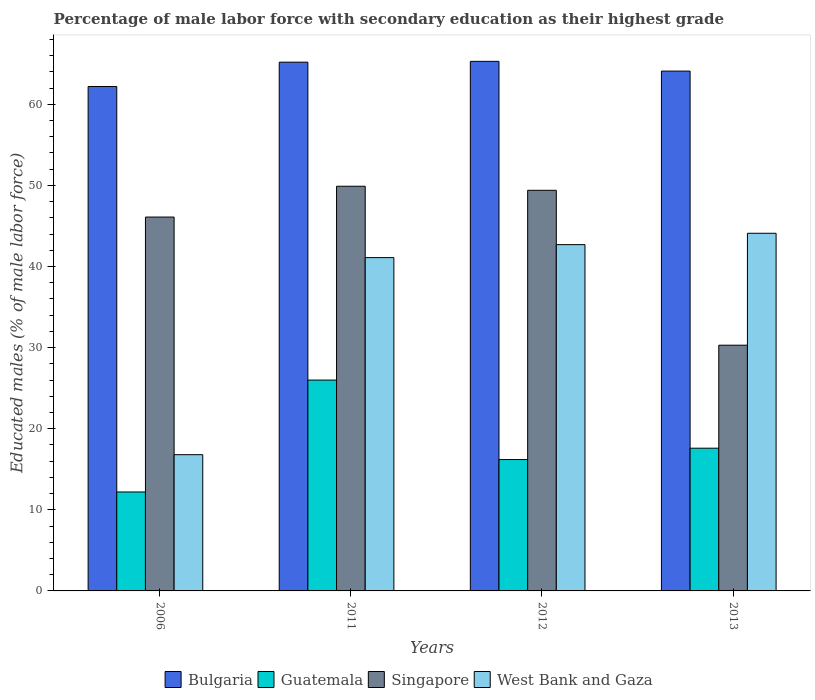How many groups of bars are there?
Your response must be concise. 4. Are the number of bars on each tick of the X-axis equal?
Offer a very short reply. Yes. How many bars are there on the 1st tick from the left?
Ensure brevity in your answer.  4. How many bars are there on the 1st tick from the right?
Keep it short and to the point. 4. What is the label of the 2nd group of bars from the left?
Keep it short and to the point. 2011. In how many cases, is the number of bars for a given year not equal to the number of legend labels?
Provide a short and direct response. 0. What is the percentage of male labor force with secondary education in Bulgaria in 2012?
Ensure brevity in your answer.  65.3. Across all years, what is the maximum percentage of male labor force with secondary education in Singapore?
Provide a short and direct response. 49.9. Across all years, what is the minimum percentage of male labor force with secondary education in West Bank and Gaza?
Provide a succinct answer. 16.8. What is the total percentage of male labor force with secondary education in Bulgaria in the graph?
Ensure brevity in your answer.  256.8. What is the difference between the percentage of male labor force with secondary education in Bulgaria in 2006 and that in 2012?
Provide a succinct answer. -3.1. What is the difference between the percentage of male labor force with secondary education in Guatemala in 2011 and the percentage of male labor force with secondary education in West Bank and Gaza in 2013?
Your response must be concise. -18.1. What is the average percentage of male labor force with secondary education in Bulgaria per year?
Keep it short and to the point. 64.2. In the year 2011, what is the difference between the percentage of male labor force with secondary education in West Bank and Gaza and percentage of male labor force with secondary education in Guatemala?
Provide a short and direct response. 15.1. In how many years, is the percentage of male labor force with secondary education in Singapore greater than 6 %?
Your response must be concise. 4. What is the ratio of the percentage of male labor force with secondary education in West Bank and Gaza in 2011 to that in 2013?
Provide a short and direct response. 0.93. Is the difference between the percentage of male labor force with secondary education in West Bank and Gaza in 2006 and 2011 greater than the difference between the percentage of male labor force with secondary education in Guatemala in 2006 and 2011?
Give a very brief answer. No. What is the difference between the highest and the second highest percentage of male labor force with secondary education in Guatemala?
Provide a succinct answer. 8.4. What is the difference between the highest and the lowest percentage of male labor force with secondary education in Guatemala?
Your answer should be compact. 13.8. Is the sum of the percentage of male labor force with secondary education in Bulgaria in 2011 and 2013 greater than the maximum percentage of male labor force with secondary education in West Bank and Gaza across all years?
Ensure brevity in your answer.  Yes. Is it the case that in every year, the sum of the percentage of male labor force with secondary education in West Bank and Gaza and percentage of male labor force with secondary education in Bulgaria is greater than the sum of percentage of male labor force with secondary education in Guatemala and percentage of male labor force with secondary education in Singapore?
Provide a succinct answer. Yes. What does the 3rd bar from the left in 2006 represents?
Provide a succinct answer. Singapore. What does the 4th bar from the right in 2006 represents?
Ensure brevity in your answer.  Bulgaria. Is it the case that in every year, the sum of the percentage of male labor force with secondary education in Bulgaria and percentage of male labor force with secondary education in Guatemala is greater than the percentage of male labor force with secondary education in Singapore?
Provide a short and direct response. Yes. Are all the bars in the graph horizontal?
Keep it short and to the point. No. How many years are there in the graph?
Give a very brief answer. 4. Does the graph contain any zero values?
Provide a short and direct response. No. Does the graph contain grids?
Provide a short and direct response. No. How many legend labels are there?
Give a very brief answer. 4. What is the title of the graph?
Offer a very short reply. Percentage of male labor force with secondary education as their highest grade. Does "South Africa" appear as one of the legend labels in the graph?
Ensure brevity in your answer.  No. What is the label or title of the X-axis?
Provide a succinct answer. Years. What is the label or title of the Y-axis?
Your response must be concise. Educated males (% of male labor force). What is the Educated males (% of male labor force) in Bulgaria in 2006?
Ensure brevity in your answer.  62.2. What is the Educated males (% of male labor force) in Guatemala in 2006?
Make the answer very short. 12.2. What is the Educated males (% of male labor force) in Singapore in 2006?
Offer a very short reply. 46.1. What is the Educated males (% of male labor force) of West Bank and Gaza in 2006?
Offer a terse response. 16.8. What is the Educated males (% of male labor force) of Bulgaria in 2011?
Give a very brief answer. 65.2. What is the Educated males (% of male labor force) in Singapore in 2011?
Your answer should be very brief. 49.9. What is the Educated males (% of male labor force) of West Bank and Gaza in 2011?
Your response must be concise. 41.1. What is the Educated males (% of male labor force) in Bulgaria in 2012?
Provide a short and direct response. 65.3. What is the Educated males (% of male labor force) in Guatemala in 2012?
Give a very brief answer. 16.2. What is the Educated males (% of male labor force) in Singapore in 2012?
Offer a very short reply. 49.4. What is the Educated males (% of male labor force) in West Bank and Gaza in 2012?
Keep it short and to the point. 42.7. What is the Educated males (% of male labor force) of Bulgaria in 2013?
Make the answer very short. 64.1. What is the Educated males (% of male labor force) of Guatemala in 2013?
Ensure brevity in your answer.  17.6. What is the Educated males (% of male labor force) in Singapore in 2013?
Ensure brevity in your answer.  30.3. What is the Educated males (% of male labor force) of West Bank and Gaza in 2013?
Your answer should be compact. 44.1. Across all years, what is the maximum Educated males (% of male labor force) of Bulgaria?
Provide a short and direct response. 65.3. Across all years, what is the maximum Educated males (% of male labor force) of Guatemala?
Give a very brief answer. 26. Across all years, what is the maximum Educated males (% of male labor force) of Singapore?
Your response must be concise. 49.9. Across all years, what is the maximum Educated males (% of male labor force) in West Bank and Gaza?
Ensure brevity in your answer.  44.1. Across all years, what is the minimum Educated males (% of male labor force) in Bulgaria?
Offer a very short reply. 62.2. Across all years, what is the minimum Educated males (% of male labor force) of Guatemala?
Offer a very short reply. 12.2. Across all years, what is the minimum Educated males (% of male labor force) of Singapore?
Your answer should be compact. 30.3. Across all years, what is the minimum Educated males (% of male labor force) in West Bank and Gaza?
Give a very brief answer. 16.8. What is the total Educated males (% of male labor force) in Bulgaria in the graph?
Make the answer very short. 256.8. What is the total Educated males (% of male labor force) in Singapore in the graph?
Make the answer very short. 175.7. What is the total Educated males (% of male labor force) of West Bank and Gaza in the graph?
Offer a terse response. 144.7. What is the difference between the Educated males (% of male labor force) of Guatemala in 2006 and that in 2011?
Give a very brief answer. -13.8. What is the difference between the Educated males (% of male labor force) in Singapore in 2006 and that in 2011?
Your answer should be very brief. -3.8. What is the difference between the Educated males (% of male labor force) of West Bank and Gaza in 2006 and that in 2011?
Offer a very short reply. -24.3. What is the difference between the Educated males (% of male labor force) of Bulgaria in 2006 and that in 2012?
Offer a very short reply. -3.1. What is the difference between the Educated males (% of male labor force) in Guatemala in 2006 and that in 2012?
Offer a terse response. -4. What is the difference between the Educated males (% of male labor force) of West Bank and Gaza in 2006 and that in 2012?
Make the answer very short. -25.9. What is the difference between the Educated males (% of male labor force) in Bulgaria in 2006 and that in 2013?
Make the answer very short. -1.9. What is the difference between the Educated males (% of male labor force) in Guatemala in 2006 and that in 2013?
Your answer should be compact. -5.4. What is the difference between the Educated males (% of male labor force) in Singapore in 2006 and that in 2013?
Provide a short and direct response. 15.8. What is the difference between the Educated males (% of male labor force) of West Bank and Gaza in 2006 and that in 2013?
Offer a terse response. -27.3. What is the difference between the Educated males (% of male labor force) in West Bank and Gaza in 2011 and that in 2012?
Provide a succinct answer. -1.6. What is the difference between the Educated males (% of male labor force) of Singapore in 2011 and that in 2013?
Give a very brief answer. 19.6. What is the difference between the Educated males (% of male labor force) in West Bank and Gaza in 2011 and that in 2013?
Give a very brief answer. -3. What is the difference between the Educated males (% of male labor force) of Guatemala in 2012 and that in 2013?
Offer a terse response. -1.4. What is the difference between the Educated males (% of male labor force) in Bulgaria in 2006 and the Educated males (% of male labor force) in Guatemala in 2011?
Offer a very short reply. 36.2. What is the difference between the Educated males (% of male labor force) in Bulgaria in 2006 and the Educated males (% of male labor force) in Singapore in 2011?
Ensure brevity in your answer.  12.3. What is the difference between the Educated males (% of male labor force) in Bulgaria in 2006 and the Educated males (% of male labor force) in West Bank and Gaza in 2011?
Give a very brief answer. 21.1. What is the difference between the Educated males (% of male labor force) of Guatemala in 2006 and the Educated males (% of male labor force) of Singapore in 2011?
Give a very brief answer. -37.7. What is the difference between the Educated males (% of male labor force) in Guatemala in 2006 and the Educated males (% of male labor force) in West Bank and Gaza in 2011?
Offer a terse response. -28.9. What is the difference between the Educated males (% of male labor force) in Bulgaria in 2006 and the Educated males (% of male labor force) in Guatemala in 2012?
Provide a short and direct response. 46. What is the difference between the Educated males (% of male labor force) in Bulgaria in 2006 and the Educated males (% of male labor force) in Singapore in 2012?
Your answer should be very brief. 12.8. What is the difference between the Educated males (% of male labor force) in Bulgaria in 2006 and the Educated males (% of male labor force) in West Bank and Gaza in 2012?
Provide a short and direct response. 19.5. What is the difference between the Educated males (% of male labor force) in Guatemala in 2006 and the Educated males (% of male labor force) in Singapore in 2012?
Provide a succinct answer. -37.2. What is the difference between the Educated males (% of male labor force) in Guatemala in 2006 and the Educated males (% of male labor force) in West Bank and Gaza in 2012?
Ensure brevity in your answer.  -30.5. What is the difference between the Educated males (% of male labor force) of Bulgaria in 2006 and the Educated males (% of male labor force) of Guatemala in 2013?
Keep it short and to the point. 44.6. What is the difference between the Educated males (% of male labor force) of Bulgaria in 2006 and the Educated males (% of male labor force) of Singapore in 2013?
Provide a succinct answer. 31.9. What is the difference between the Educated males (% of male labor force) of Guatemala in 2006 and the Educated males (% of male labor force) of Singapore in 2013?
Provide a succinct answer. -18.1. What is the difference between the Educated males (% of male labor force) in Guatemala in 2006 and the Educated males (% of male labor force) in West Bank and Gaza in 2013?
Make the answer very short. -31.9. What is the difference between the Educated males (% of male labor force) in Guatemala in 2011 and the Educated males (% of male labor force) in Singapore in 2012?
Provide a short and direct response. -23.4. What is the difference between the Educated males (% of male labor force) in Guatemala in 2011 and the Educated males (% of male labor force) in West Bank and Gaza in 2012?
Provide a succinct answer. -16.7. What is the difference between the Educated males (% of male labor force) of Singapore in 2011 and the Educated males (% of male labor force) of West Bank and Gaza in 2012?
Make the answer very short. 7.2. What is the difference between the Educated males (% of male labor force) of Bulgaria in 2011 and the Educated males (% of male labor force) of Guatemala in 2013?
Provide a short and direct response. 47.6. What is the difference between the Educated males (% of male labor force) in Bulgaria in 2011 and the Educated males (% of male labor force) in Singapore in 2013?
Offer a terse response. 34.9. What is the difference between the Educated males (% of male labor force) of Bulgaria in 2011 and the Educated males (% of male labor force) of West Bank and Gaza in 2013?
Offer a very short reply. 21.1. What is the difference between the Educated males (% of male labor force) of Guatemala in 2011 and the Educated males (% of male labor force) of Singapore in 2013?
Provide a short and direct response. -4.3. What is the difference between the Educated males (% of male labor force) of Guatemala in 2011 and the Educated males (% of male labor force) of West Bank and Gaza in 2013?
Make the answer very short. -18.1. What is the difference between the Educated males (% of male labor force) in Bulgaria in 2012 and the Educated males (% of male labor force) in Guatemala in 2013?
Offer a very short reply. 47.7. What is the difference between the Educated males (% of male labor force) of Bulgaria in 2012 and the Educated males (% of male labor force) of West Bank and Gaza in 2013?
Provide a succinct answer. 21.2. What is the difference between the Educated males (% of male labor force) in Guatemala in 2012 and the Educated males (% of male labor force) in Singapore in 2013?
Your answer should be very brief. -14.1. What is the difference between the Educated males (% of male labor force) in Guatemala in 2012 and the Educated males (% of male labor force) in West Bank and Gaza in 2013?
Your response must be concise. -27.9. What is the difference between the Educated males (% of male labor force) of Singapore in 2012 and the Educated males (% of male labor force) of West Bank and Gaza in 2013?
Your answer should be compact. 5.3. What is the average Educated males (% of male labor force) of Bulgaria per year?
Ensure brevity in your answer.  64.2. What is the average Educated males (% of male labor force) in Singapore per year?
Provide a short and direct response. 43.92. What is the average Educated males (% of male labor force) of West Bank and Gaza per year?
Your response must be concise. 36.17. In the year 2006, what is the difference between the Educated males (% of male labor force) in Bulgaria and Educated males (% of male labor force) in Guatemala?
Give a very brief answer. 50. In the year 2006, what is the difference between the Educated males (% of male labor force) in Bulgaria and Educated males (% of male labor force) in West Bank and Gaza?
Provide a short and direct response. 45.4. In the year 2006, what is the difference between the Educated males (% of male labor force) in Guatemala and Educated males (% of male labor force) in Singapore?
Provide a succinct answer. -33.9. In the year 2006, what is the difference between the Educated males (% of male labor force) of Guatemala and Educated males (% of male labor force) of West Bank and Gaza?
Your response must be concise. -4.6. In the year 2006, what is the difference between the Educated males (% of male labor force) in Singapore and Educated males (% of male labor force) in West Bank and Gaza?
Make the answer very short. 29.3. In the year 2011, what is the difference between the Educated males (% of male labor force) of Bulgaria and Educated males (% of male labor force) of Guatemala?
Keep it short and to the point. 39.2. In the year 2011, what is the difference between the Educated males (% of male labor force) in Bulgaria and Educated males (% of male labor force) in West Bank and Gaza?
Ensure brevity in your answer.  24.1. In the year 2011, what is the difference between the Educated males (% of male labor force) in Guatemala and Educated males (% of male labor force) in Singapore?
Your response must be concise. -23.9. In the year 2011, what is the difference between the Educated males (% of male labor force) of Guatemala and Educated males (% of male labor force) of West Bank and Gaza?
Offer a terse response. -15.1. In the year 2012, what is the difference between the Educated males (% of male labor force) of Bulgaria and Educated males (% of male labor force) of Guatemala?
Your response must be concise. 49.1. In the year 2012, what is the difference between the Educated males (% of male labor force) of Bulgaria and Educated males (% of male labor force) of Singapore?
Make the answer very short. 15.9. In the year 2012, what is the difference between the Educated males (% of male labor force) in Bulgaria and Educated males (% of male labor force) in West Bank and Gaza?
Offer a terse response. 22.6. In the year 2012, what is the difference between the Educated males (% of male labor force) of Guatemala and Educated males (% of male labor force) of Singapore?
Ensure brevity in your answer.  -33.2. In the year 2012, what is the difference between the Educated males (% of male labor force) in Guatemala and Educated males (% of male labor force) in West Bank and Gaza?
Make the answer very short. -26.5. In the year 2012, what is the difference between the Educated males (% of male labor force) in Singapore and Educated males (% of male labor force) in West Bank and Gaza?
Make the answer very short. 6.7. In the year 2013, what is the difference between the Educated males (% of male labor force) of Bulgaria and Educated males (% of male labor force) of Guatemala?
Provide a succinct answer. 46.5. In the year 2013, what is the difference between the Educated males (% of male labor force) of Bulgaria and Educated males (% of male labor force) of Singapore?
Give a very brief answer. 33.8. In the year 2013, what is the difference between the Educated males (% of male labor force) in Guatemala and Educated males (% of male labor force) in West Bank and Gaza?
Provide a succinct answer. -26.5. In the year 2013, what is the difference between the Educated males (% of male labor force) in Singapore and Educated males (% of male labor force) in West Bank and Gaza?
Make the answer very short. -13.8. What is the ratio of the Educated males (% of male labor force) of Bulgaria in 2006 to that in 2011?
Offer a very short reply. 0.95. What is the ratio of the Educated males (% of male labor force) in Guatemala in 2006 to that in 2011?
Make the answer very short. 0.47. What is the ratio of the Educated males (% of male labor force) in Singapore in 2006 to that in 2011?
Give a very brief answer. 0.92. What is the ratio of the Educated males (% of male labor force) of West Bank and Gaza in 2006 to that in 2011?
Offer a terse response. 0.41. What is the ratio of the Educated males (% of male labor force) of Bulgaria in 2006 to that in 2012?
Ensure brevity in your answer.  0.95. What is the ratio of the Educated males (% of male labor force) of Guatemala in 2006 to that in 2012?
Give a very brief answer. 0.75. What is the ratio of the Educated males (% of male labor force) in Singapore in 2006 to that in 2012?
Ensure brevity in your answer.  0.93. What is the ratio of the Educated males (% of male labor force) of West Bank and Gaza in 2006 to that in 2012?
Provide a short and direct response. 0.39. What is the ratio of the Educated males (% of male labor force) of Bulgaria in 2006 to that in 2013?
Your response must be concise. 0.97. What is the ratio of the Educated males (% of male labor force) in Guatemala in 2006 to that in 2013?
Keep it short and to the point. 0.69. What is the ratio of the Educated males (% of male labor force) in Singapore in 2006 to that in 2013?
Provide a succinct answer. 1.52. What is the ratio of the Educated males (% of male labor force) in West Bank and Gaza in 2006 to that in 2013?
Ensure brevity in your answer.  0.38. What is the ratio of the Educated males (% of male labor force) in Bulgaria in 2011 to that in 2012?
Provide a short and direct response. 1. What is the ratio of the Educated males (% of male labor force) of Guatemala in 2011 to that in 2012?
Provide a succinct answer. 1.6. What is the ratio of the Educated males (% of male labor force) in West Bank and Gaza in 2011 to that in 2012?
Your answer should be compact. 0.96. What is the ratio of the Educated males (% of male labor force) of Bulgaria in 2011 to that in 2013?
Provide a short and direct response. 1.02. What is the ratio of the Educated males (% of male labor force) of Guatemala in 2011 to that in 2013?
Your answer should be very brief. 1.48. What is the ratio of the Educated males (% of male labor force) in Singapore in 2011 to that in 2013?
Your response must be concise. 1.65. What is the ratio of the Educated males (% of male labor force) of West Bank and Gaza in 2011 to that in 2013?
Give a very brief answer. 0.93. What is the ratio of the Educated males (% of male labor force) of Bulgaria in 2012 to that in 2013?
Give a very brief answer. 1.02. What is the ratio of the Educated males (% of male labor force) of Guatemala in 2012 to that in 2013?
Keep it short and to the point. 0.92. What is the ratio of the Educated males (% of male labor force) in Singapore in 2012 to that in 2013?
Make the answer very short. 1.63. What is the ratio of the Educated males (% of male labor force) of West Bank and Gaza in 2012 to that in 2013?
Give a very brief answer. 0.97. What is the difference between the highest and the second highest Educated males (% of male labor force) of Bulgaria?
Provide a succinct answer. 0.1. What is the difference between the highest and the second highest Educated males (% of male labor force) of West Bank and Gaza?
Provide a succinct answer. 1.4. What is the difference between the highest and the lowest Educated males (% of male labor force) in Singapore?
Offer a terse response. 19.6. What is the difference between the highest and the lowest Educated males (% of male labor force) of West Bank and Gaza?
Ensure brevity in your answer.  27.3. 